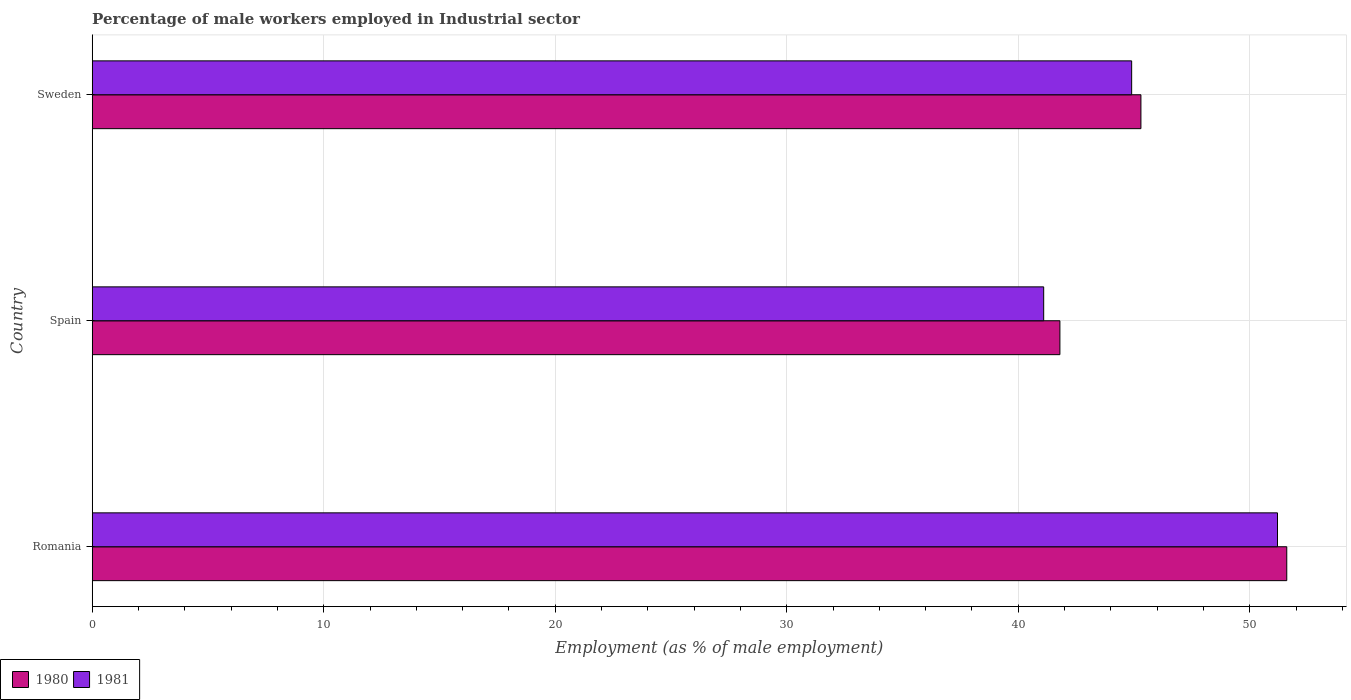How many groups of bars are there?
Your answer should be compact. 3. Are the number of bars per tick equal to the number of legend labels?
Offer a very short reply. Yes. How many bars are there on the 3rd tick from the bottom?
Your answer should be very brief. 2. What is the label of the 2nd group of bars from the top?
Provide a succinct answer. Spain. In how many cases, is the number of bars for a given country not equal to the number of legend labels?
Provide a short and direct response. 0. What is the percentage of male workers employed in Industrial sector in 1981 in Spain?
Your answer should be compact. 41.1. Across all countries, what is the maximum percentage of male workers employed in Industrial sector in 1981?
Provide a short and direct response. 51.2. Across all countries, what is the minimum percentage of male workers employed in Industrial sector in 1981?
Your answer should be compact. 41.1. In which country was the percentage of male workers employed in Industrial sector in 1980 maximum?
Keep it short and to the point. Romania. What is the total percentage of male workers employed in Industrial sector in 1981 in the graph?
Give a very brief answer. 137.2. What is the difference between the percentage of male workers employed in Industrial sector in 1981 in Romania and that in Sweden?
Keep it short and to the point. 6.3. What is the difference between the percentage of male workers employed in Industrial sector in 1981 in Spain and the percentage of male workers employed in Industrial sector in 1980 in Sweden?
Give a very brief answer. -4.2. What is the average percentage of male workers employed in Industrial sector in 1980 per country?
Make the answer very short. 46.23. What is the difference between the percentage of male workers employed in Industrial sector in 1981 and percentage of male workers employed in Industrial sector in 1980 in Sweden?
Make the answer very short. -0.4. What is the ratio of the percentage of male workers employed in Industrial sector in 1980 in Romania to that in Sweden?
Your answer should be very brief. 1.14. Is the difference between the percentage of male workers employed in Industrial sector in 1981 in Romania and Spain greater than the difference between the percentage of male workers employed in Industrial sector in 1980 in Romania and Spain?
Your answer should be compact. Yes. What is the difference between the highest and the second highest percentage of male workers employed in Industrial sector in 1981?
Make the answer very short. 6.3. What is the difference between the highest and the lowest percentage of male workers employed in Industrial sector in 1981?
Make the answer very short. 10.1. Is the sum of the percentage of male workers employed in Industrial sector in 1980 in Spain and Sweden greater than the maximum percentage of male workers employed in Industrial sector in 1981 across all countries?
Provide a short and direct response. Yes. What does the 2nd bar from the bottom in Spain represents?
Ensure brevity in your answer.  1981. How many bars are there?
Offer a terse response. 6. Are the values on the major ticks of X-axis written in scientific E-notation?
Your response must be concise. No. Does the graph contain any zero values?
Your answer should be compact. No. Where does the legend appear in the graph?
Provide a succinct answer. Bottom left. How many legend labels are there?
Offer a terse response. 2. What is the title of the graph?
Offer a terse response. Percentage of male workers employed in Industrial sector. Does "1964" appear as one of the legend labels in the graph?
Make the answer very short. No. What is the label or title of the X-axis?
Provide a short and direct response. Employment (as % of male employment). What is the label or title of the Y-axis?
Keep it short and to the point. Country. What is the Employment (as % of male employment) of 1980 in Romania?
Ensure brevity in your answer.  51.6. What is the Employment (as % of male employment) in 1981 in Romania?
Make the answer very short. 51.2. What is the Employment (as % of male employment) of 1980 in Spain?
Provide a succinct answer. 41.8. What is the Employment (as % of male employment) of 1981 in Spain?
Your response must be concise. 41.1. What is the Employment (as % of male employment) of 1980 in Sweden?
Your answer should be very brief. 45.3. What is the Employment (as % of male employment) of 1981 in Sweden?
Offer a terse response. 44.9. Across all countries, what is the maximum Employment (as % of male employment) of 1980?
Offer a very short reply. 51.6. Across all countries, what is the maximum Employment (as % of male employment) in 1981?
Offer a terse response. 51.2. Across all countries, what is the minimum Employment (as % of male employment) of 1980?
Offer a terse response. 41.8. Across all countries, what is the minimum Employment (as % of male employment) in 1981?
Your response must be concise. 41.1. What is the total Employment (as % of male employment) in 1980 in the graph?
Provide a succinct answer. 138.7. What is the total Employment (as % of male employment) in 1981 in the graph?
Your answer should be compact. 137.2. What is the difference between the Employment (as % of male employment) of 1981 in Romania and that in Sweden?
Make the answer very short. 6.3. What is the difference between the Employment (as % of male employment) in 1980 in Romania and the Employment (as % of male employment) in 1981 in Sweden?
Ensure brevity in your answer.  6.7. What is the average Employment (as % of male employment) of 1980 per country?
Your answer should be very brief. 46.23. What is the average Employment (as % of male employment) of 1981 per country?
Your response must be concise. 45.73. What is the difference between the Employment (as % of male employment) in 1980 and Employment (as % of male employment) in 1981 in Romania?
Your answer should be compact. 0.4. What is the difference between the Employment (as % of male employment) of 1980 and Employment (as % of male employment) of 1981 in Spain?
Give a very brief answer. 0.7. What is the ratio of the Employment (as % of male employment) of 1980 in Romania to that in Spain?
Your answer should be very brief. 1.23. What is the ratio of the Employment (as % of male employment) of 1981 in Romania to that in Spain?
Make the answer very short. 1.25. What is the ratio of the Employment (as % of male employment) in 1980 in Romania to that in Sweden?
Your answer should be compact. 1.14. What is the ratio of the Employment (as % of male employment) of 1981 in Romania to that in Sweden?
Offer a terse response. 1.14. What is the ratio of the Employment (as % of male employment) in 1980 in Spain to that in Sweden?
Offer a terse response. 0.92. What is the ratio of the Employment (as % of male employment) of 1981 in Spain to that in Sweden?
Offer a terse response. 0.92. What is the difference between the highest and the second highest Employment (as % of male employment) in 1980?
Provide a succinct answer. 6.3. What is the difference between the highest and the lowest Employment (as % of male employment) in 1981?
Your answer should be very brief. 10.1. 